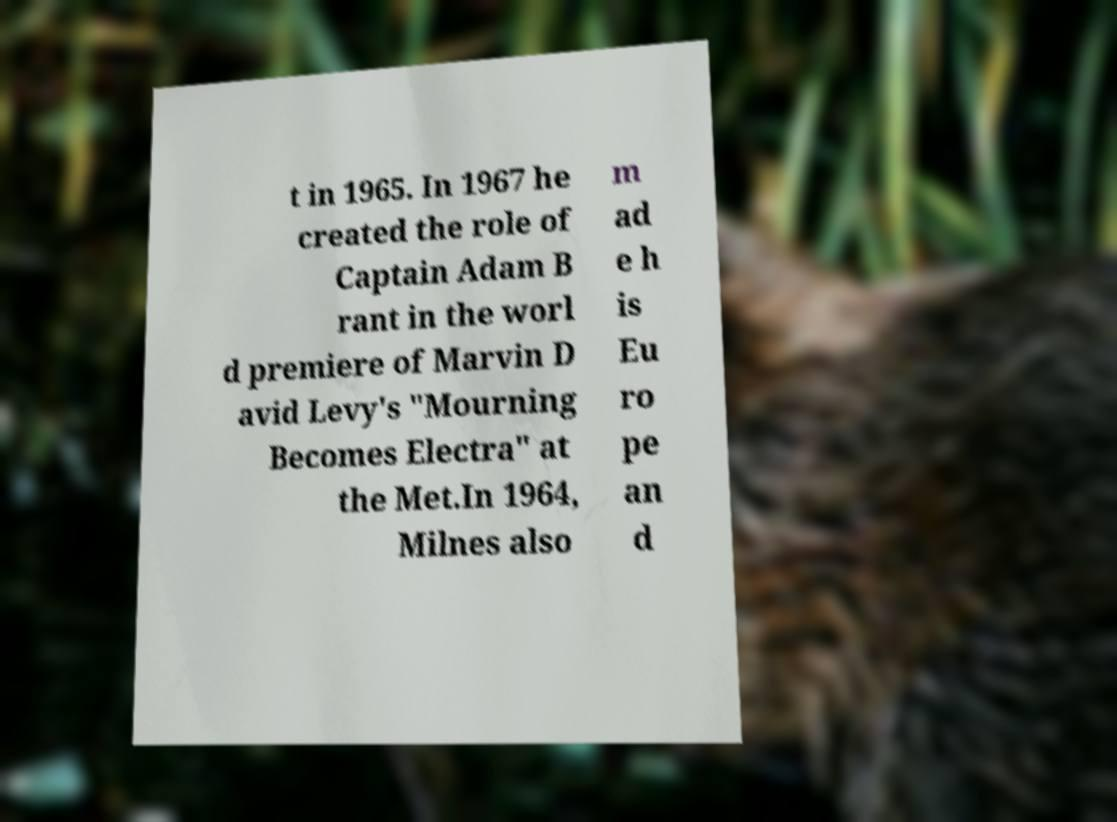Can you accurately transcribe the text from the provided image for me? t in 1965. In 1967 he created the role of Captain Adam B rant in the worl d premiere of Marvin D avid Levy's "Mourning Becomes Electra" at the Met.In 1964, Milnes also m ad e h is Eu ro pe an d 